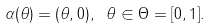Convert formula to latex. <formula><loc_0><loc_0><loc_500><loc_500>\alpha ( \theta ) = ( \theta , 0 ) , \ \theta \in \Theta = [ 0 , 1 ] .</formula> 